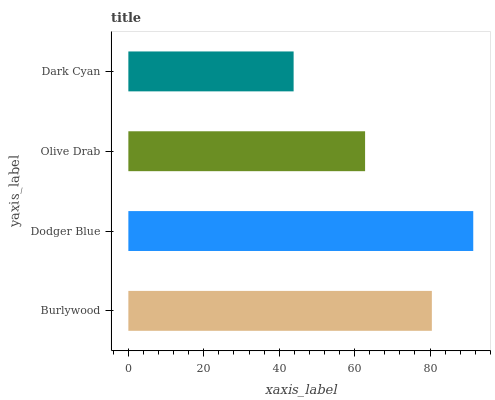Is Dark Cyan the minimum?
Answer yes or no. Yes. Is Dodger Blue the maximum?
Answer yes or no. Yes. Is Olive Drab the minimum?
Answer yes or no. No. Is Olive Drab the maximum?
Answer yes or no. No. Is Dodger Blue greater than Olive Drab?
Answer yes or no. Yes. Is Olive Drab less than Dodger Blue?
Answer yes or no. Yes. Is Olive Drab greater than Dodger Blue?
Answer yes or no. No. Is Dodger Blue less than Olive Drab?
Answer yes or no. No. Is Burlywood the high median?
Answer yes or no. Yes. Is Olive Drab the low median?
Answer yes or no. Yes. Is Dodger Blue the high median?
Answer yes or no. No. Is Dark Cyan the low median?
Answer yes or no. No. 